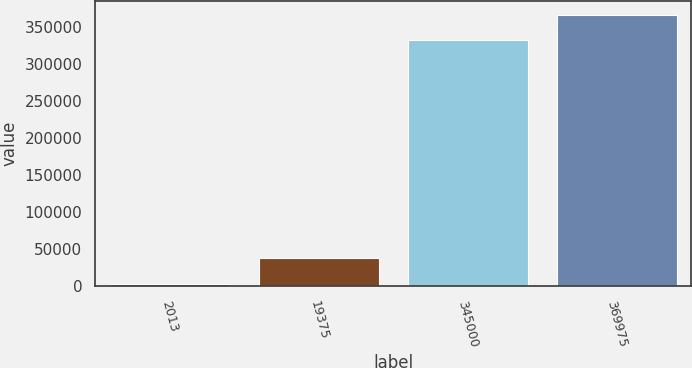<chart> <loc_0><loc_0><loc_500><loc_500><bar_chart><fcel>2013<fcel>19375<fcel>345000<fcel>369975<nl><fcel>2012<fcel>37010.8<fcel>332000<fcel>366999<nl></chart> 